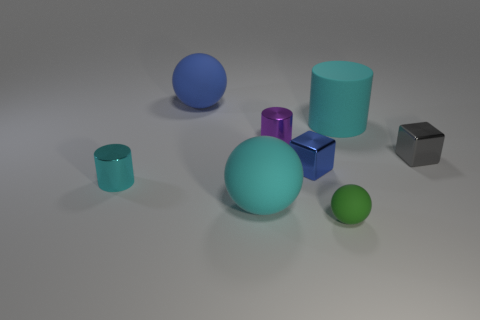Add 2 green rubber spheres. How many objects exist? 10 Subtract all cylinders. How many objects are left? 5 Subtract 0 blue cylinders. How many objects are left? 8 Subtract all tiny green matte balls. Subtract all blue shiny blocks. How many objects are left? 6 Add 4 cyan shiny cylinders. How many cyan shiny cylinders are left? 5 Add 5 large yellow rubber objects. How many large yellow rubber objects exist? 5 